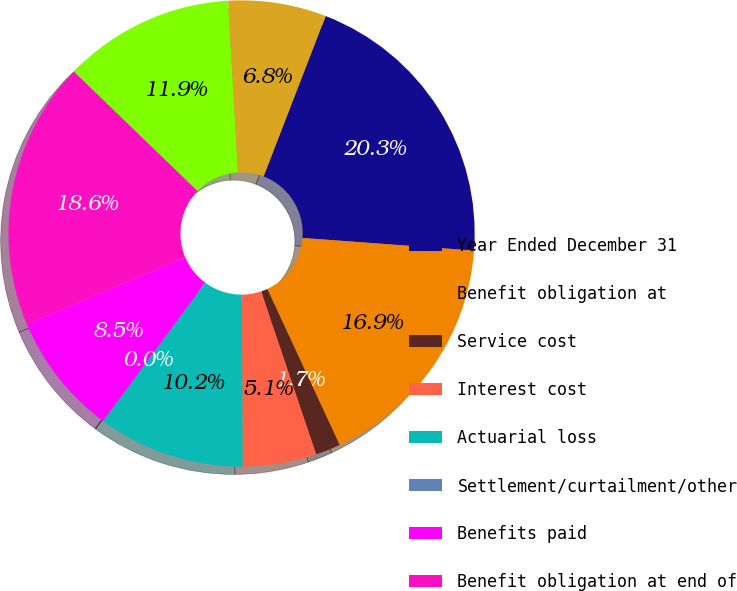<chart> <loc_0><loc_0><loc_500><loc_500><pie_chart><fcel>Year Ended December 31<fcel>Benefit obligation at<fcel>Service cost<fcel>Interest cost<fcel>Actuarial loss<fcel>Settlement/curtailment/other<fcel>Benefits paid<fcel>Benefit obligation at end of<fcel>Fair value of assets at<fcel>Actual return on plan assets<nl><fcel>20.3%<fcel>16.92%<fcel>1.73%<fcel>5.11%<fcel>10.17%<fcel>0.04%<fcel>8.48%<fcel>18.61%<fcel>11.86%<fcel>6.79%<nl></chart> 